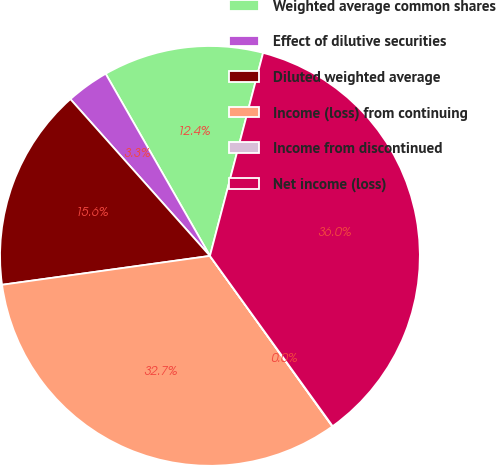Convert chart. <chart><loc_0><loc_0><loc_500><loc_500><pie_chart><fcel>Weighted average common shares<fcel>Effect of dilutive securities<fcel>Diluted weighted average<fcel>Income (loss) from continuing<fcel>Income from discontinued<fcel>Net income (loss)<nl><fcel>12.35%<fcel>3.3%<fcel>15.62%<fcel>32.71%<fcel>0.03%<fcel>35.98%<nl></chart> 